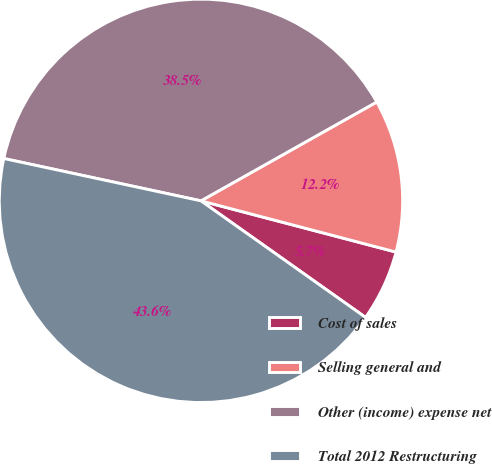Convert chart to OTSL. <chart><loc_0><loc_0><loc_500><loc_500><pie_chart><fcel>Cost of sales<fcel>Selling general and<fcel>Other (income) expense net<fcel>Total 2012 Restructuring<nl><fcel>5.72%<fcel>12.24%<fcel>38.48%<fcel>43.56%<nl></chart> 